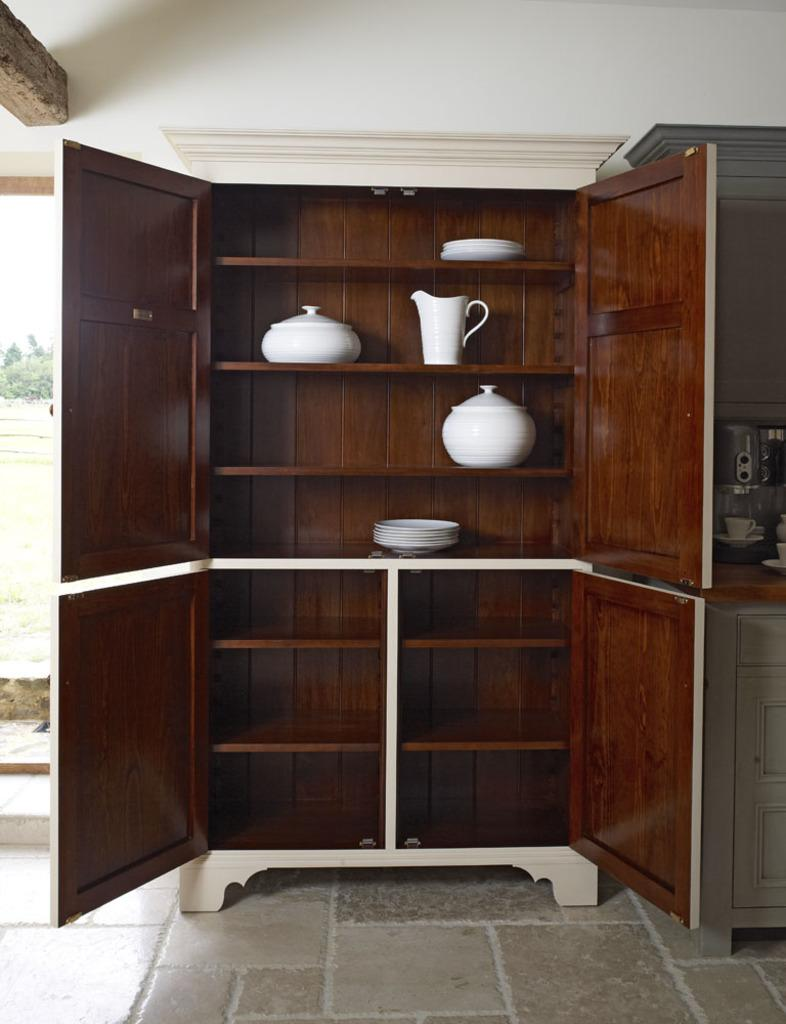What type of objects can be seen on the table in the image? There are objects on a table in the image. What type of objects are inside the cupboard in the image? There are objects inside a cupboard in the image. What type of objects are visible on the plates in the image? The provided facts do not mention any objects on the plates. What color is the wall visible in the image? There is a white-colored wall visible in the image. How many brothers are depicted in the scene in the image? There is no scene or brothers present in the image. What type of produce can be seen growing on the white-colored wall in the image? There is no produce visible on the white-colored wall in the image. 